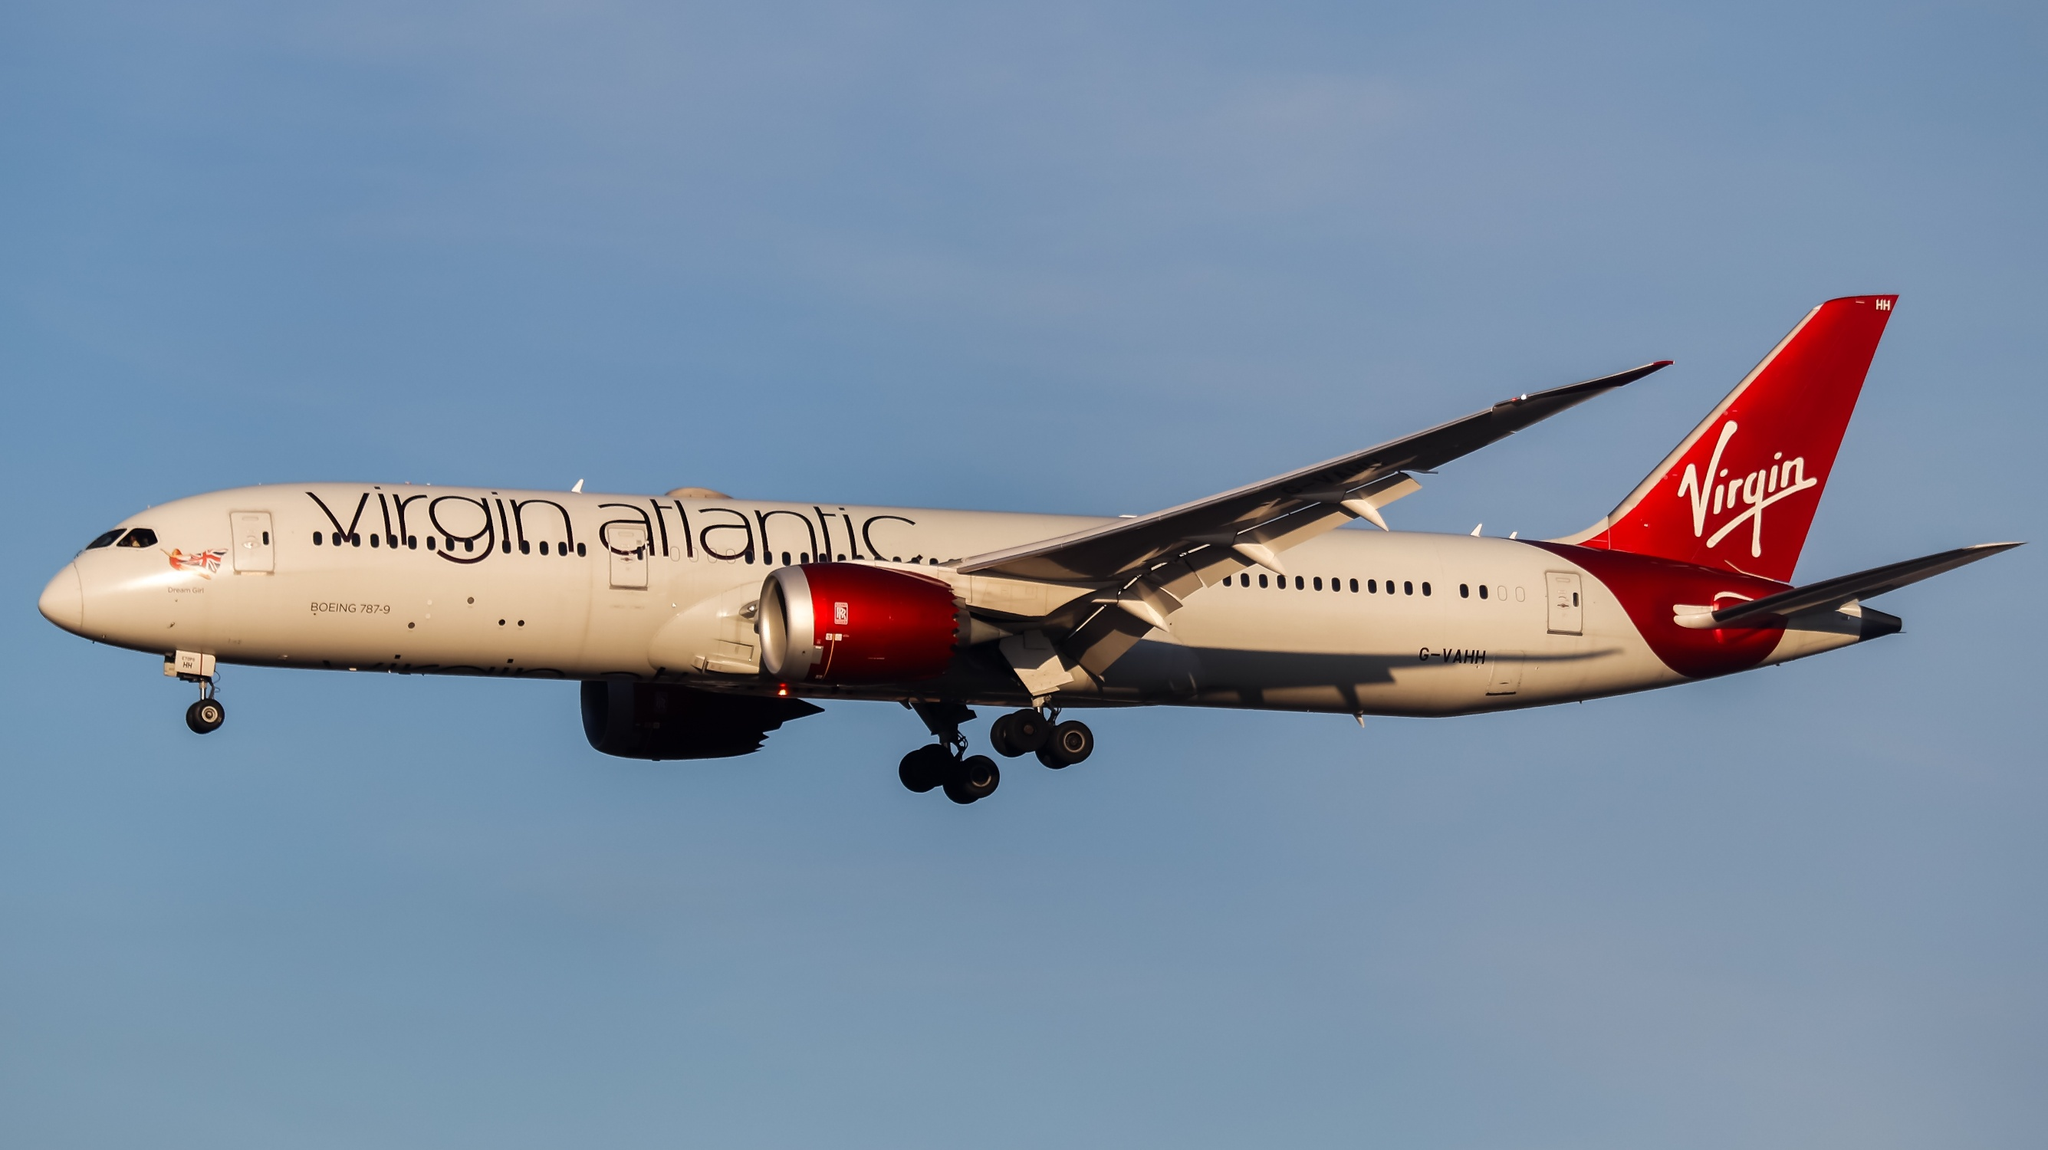Imagine this airplane is embarking on a mystical journey. Describe its adventure. As the sun begins to set, casting a golden glow across the sky, the Virgin Atlantic Boeing 787-9 Dreamliner embarks on an extraordinary adventure. The aircraft, adorned in its gleaming livery, ascends into the twilight, where it encounters an aurora of shimmering colors. Guided by celestial constellations, the Dreamliner glides effortlessly above an ocean of clouds, embarking on a journey not bound by earthly destinations. As it soars through the night, it crosses paths with mythical creatures and navigates through ethereal landscapes painted by the stars. This mystical odyssey takes the airplane to realms unseen by human eyes, where dreams and reality converge, and the possibilities of the universe unfold in an endless tapestry of wonder. 